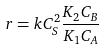<formula> <loc_0><loc_0><loc_500><loc_500>r = k C _ { S } ^ { 2 } \frac { K _ { 2 } C _ { B } } { K _ { 1 } C _ { A } }</formula> 